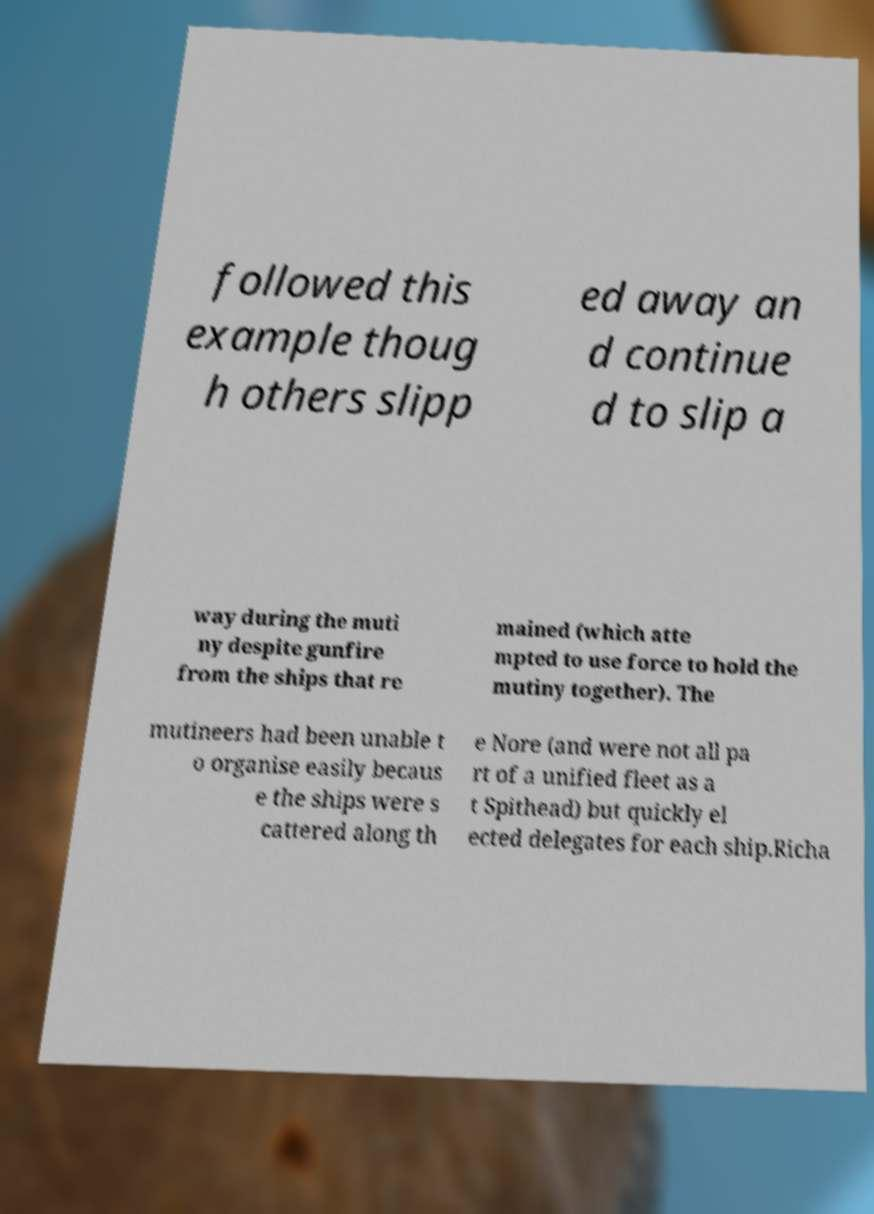Please read and relay the text visible in this image. What does it say? followed this example thoug h others slipp ed away an d continue d to slip a way during the muti ny despite gunfire from the ships that re mained (which atte mpted to use force to hold the mutiny together). The mutineers had been unable t o organise easily becaus e the ships were s cattered along th e Nore (and were not all pa rt of a unified fleet as a t Spithead) but quickly el ected delegates for each ship.Richa 